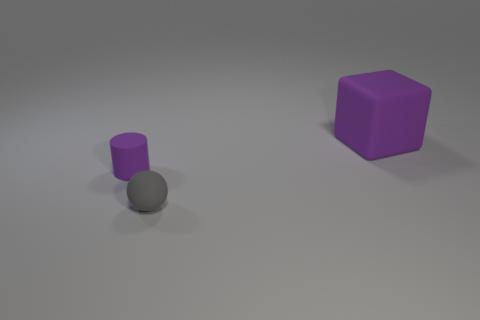There is a tiny purple thing; what shape is it?
Ensure brevity in your answer.  Cylinder. What shape is the rubber thing that is in front of the big purple rubber object and to the right of the small rubber cylinder?
Provide a short and direct response. Sphere. What color is the tiny cylinder that is made of the same material as the large thing?
Make the answer very short. Purple. There is a purple rubber thing left of the purple object behind the tiny thing behind the small gray object; what shape is it?
Provide a succinct answer. Cylinder. What size is the gray sphere?
Provide a succinct answer. Small. The gray thing that is made of the same material as the small purple thing is what shape?
Offer a very short reply. Sphere. Are there fewer rubber cylinders in front of the tiny cylinder than large green cubes?
Your answer should be very brief. No. There is a thing that is behind the small cylinder; what is its color?
Make the answer very short. Purple. There is a large block that is the same color as the rubber cylinder; what material is it?
Your response must be concise. Rubber. Is there a tiny gray matte thing of the same shape as the small purple thing?
Your answer should be compact. No. 